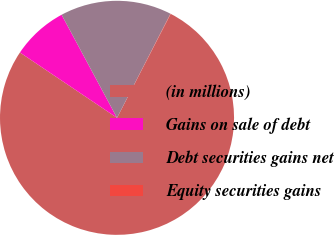Convert chart to OTSL. <chart><loc_0><loc_0><loc_500><loc_500><pie_chart><fcel>(in millions)<fcel>Gains on sale of debt<fcel>Debt securities gains net<fcel>Equity securities gains<nl><fcel>76.84%<fcel>7.72%<fcel>15.4%<fcel>0.04%<nl></chart> 